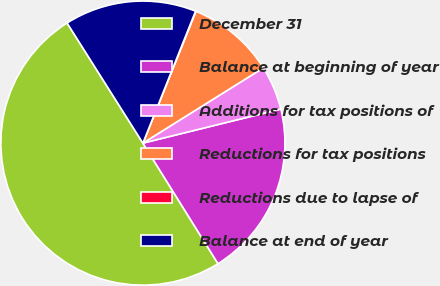Convert chart. <chart><loc_0><loc_0><loc_500><loc_500><pie_chart><fcel>December 31<fcel>Balance at beginning of year<fcel>Additions for tax positions of<fcel>Reductions for tax positions<fcel>Reductions due to lapse of<fcel>Balance at end of year<nl><fcel>49.9%<fcel>19.99%<fcel>5.03%<fcel>10.02%<fcel>0.05%<fcel>15.0%<nl></chart> 